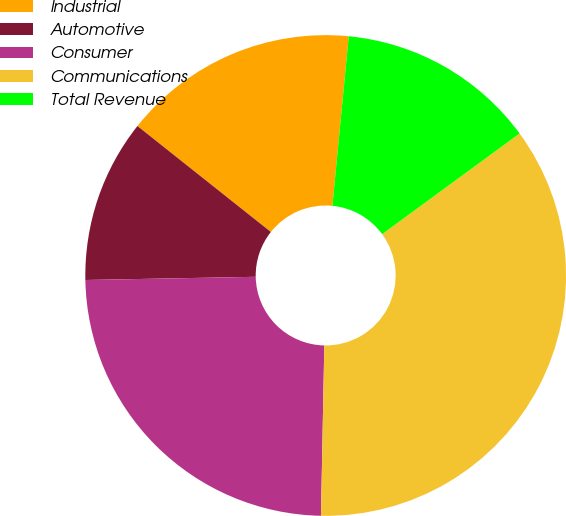Convert chart to OTSL. <chart><loc_0><loc_0><loc_500><loc_500><pie_chart><fcel>Industrial<fcel>Automotive<fcel>Consumer<fcel>Communications<fcel>Total Revenue<nl><fcel>15.85%<fcel>10.98%<fcel>24.39%<fcel>35.37%<fcel>13.41%<nl></chart> 